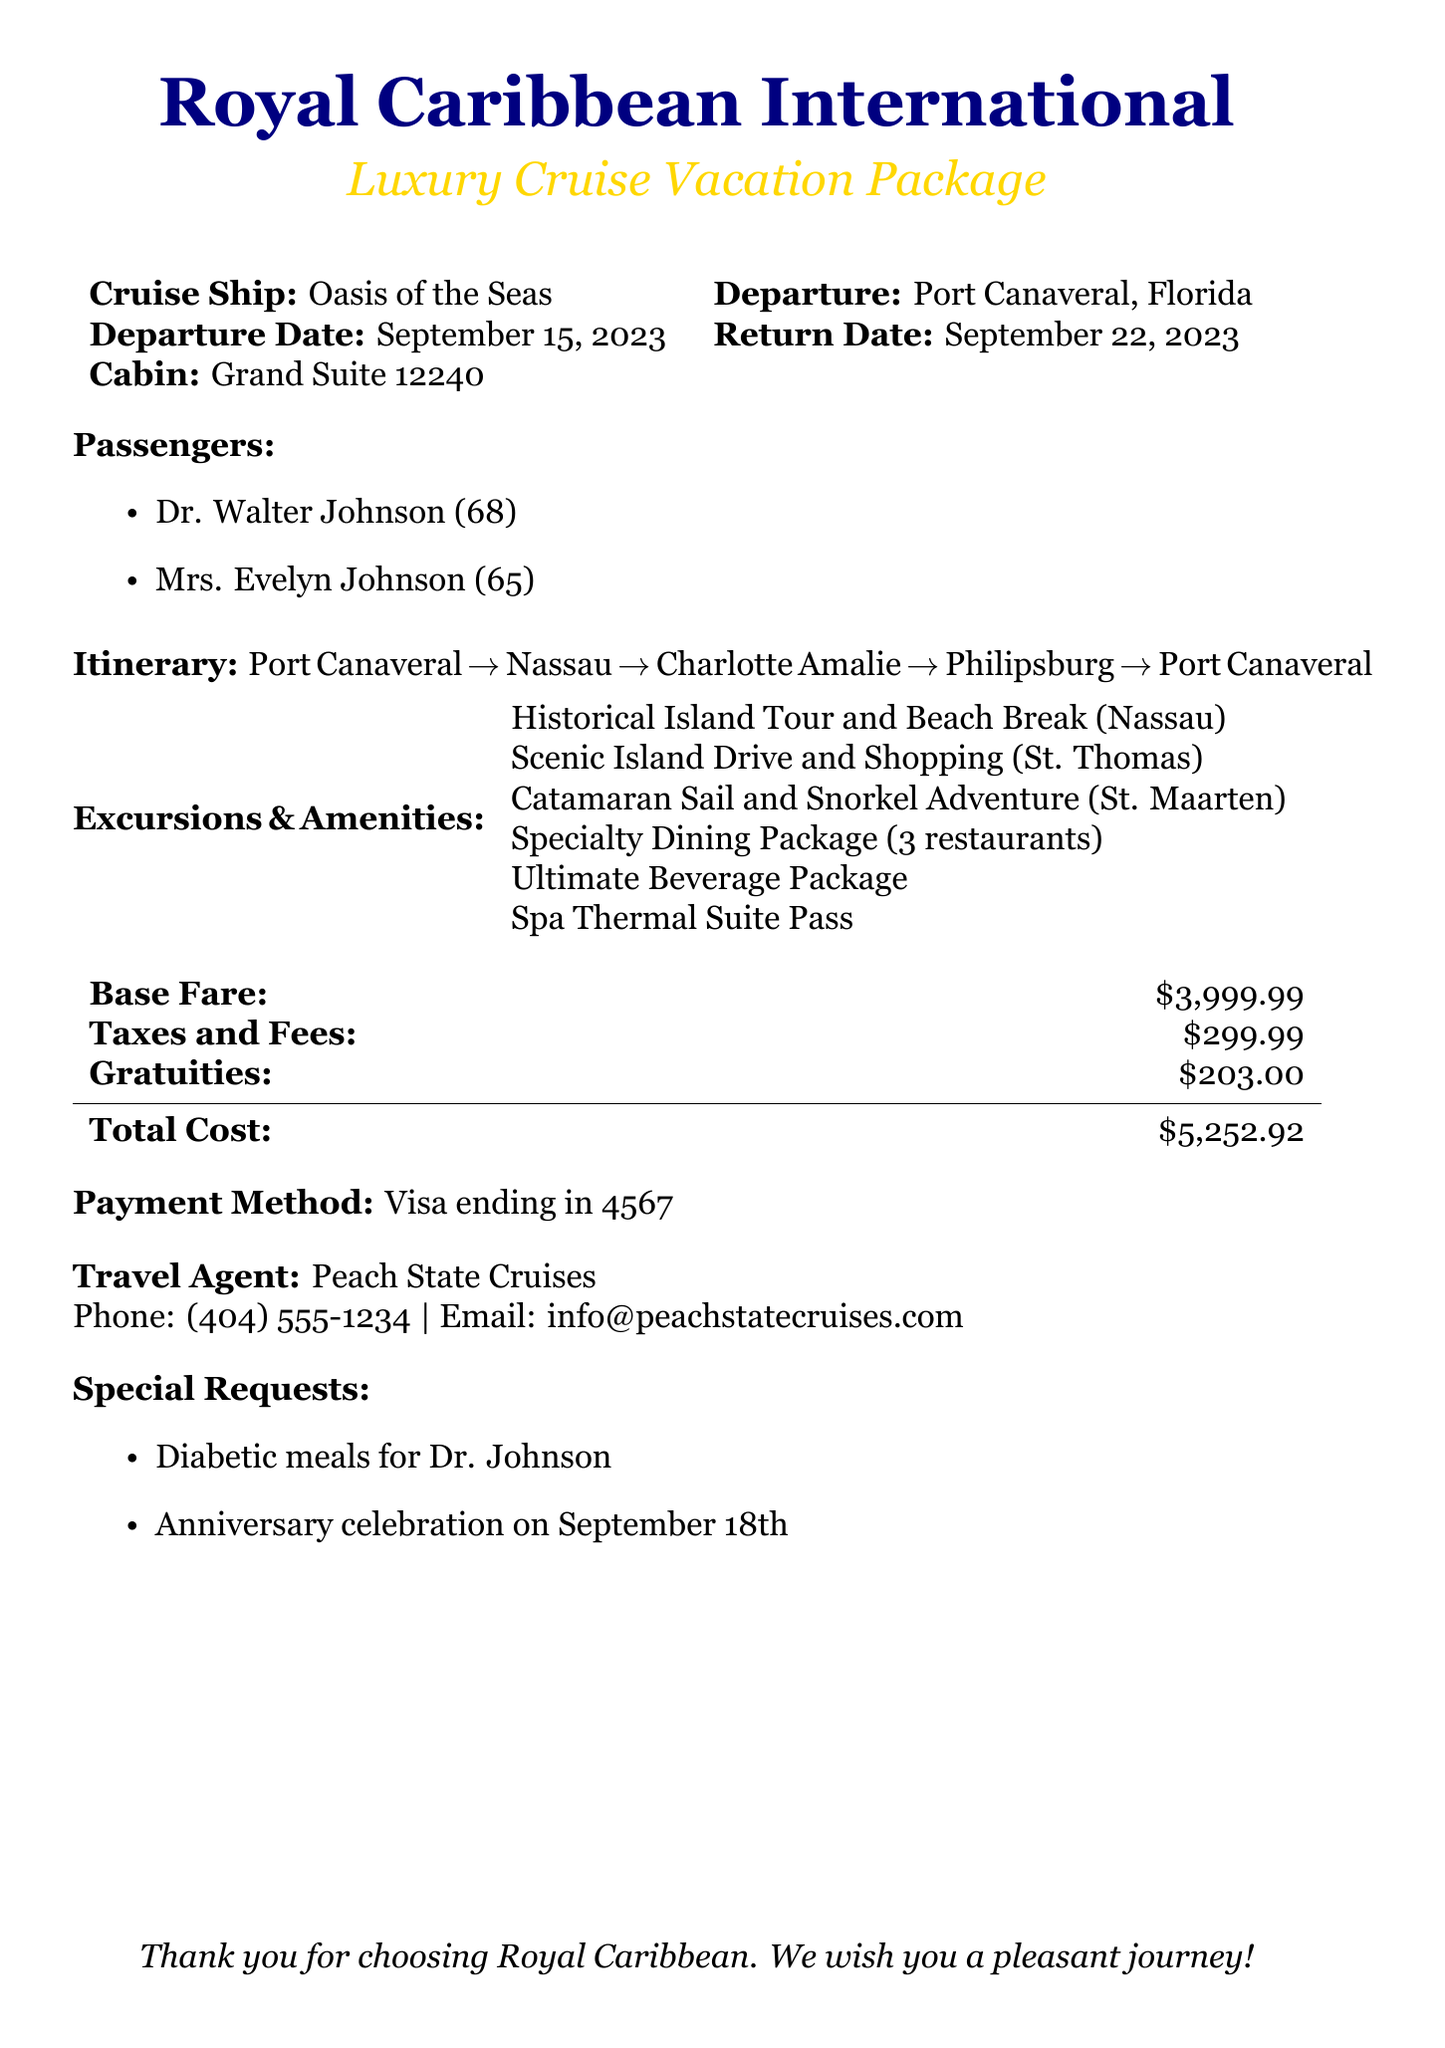what is the departure date? The departure date is stated specifically in the document under the cruise details.
Answer: September 15, 2023 what is the total cost of the vacation package? The total cost is calculated based on the base fare, taxes, fees, and gratuities listed in the document.
Answer: $5,252.92 who are the passengers on this cruise? The passengers are listed with their names and ages in the document.
Answer: Dr. Walter Johnson and Mrs. Evelyn Johnson which cabin type is booked for this cruise? The cabin type is explicitly mentioned in the document.
Answer: Grand Suite 12240 what is one of the special requests made for the cruise? The document lists special requests that were made, indicating individual needs.
Answer: Diabetic meals for Dr. Johnson how many excursions are offered in the package? By counting the excursions listed in the 'Excursions & Amenities' section, we can determine this number.
Answer: 3 what is the name of the travel agency? The travel agency's name is provided at the end of the document.
Answer: Peach State Cruises when is the anniversary celebration planned during the cruise? The anniversary celebration date is specified in the special requests section.
Answer: September 18th what is included in the ultimate beverage package? The ultimate beverage package is mentioned, but details about contents are not specified, only the cost and name are mentioned.
Answer: Not specified in the document 